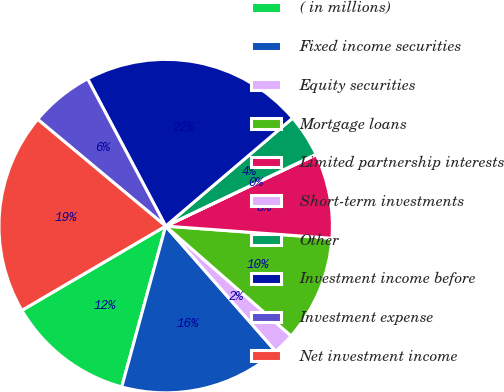<chart> <loc_0><loc_0><loc_500><loc_500><pie_chart><fcel>( in millions)<fcel>Fixed income securities<fcel>Equity securities<fcel>Mortgage loans<fcel>Limited partnership interests<fcel>Short-term investments<fcel>Other<fcel>Investment income before<fcel>Investment expense<fcel>Net investment income<nl><fcel>12.32%<fcel>15.72%<fcel>2.08%<fcel>10.28%<fcel>8.23%<fcel>0.03%<fcel>4.13%<fcel>21.54%<fcel>6.18%<fcel>19.5%<nl></chart> 